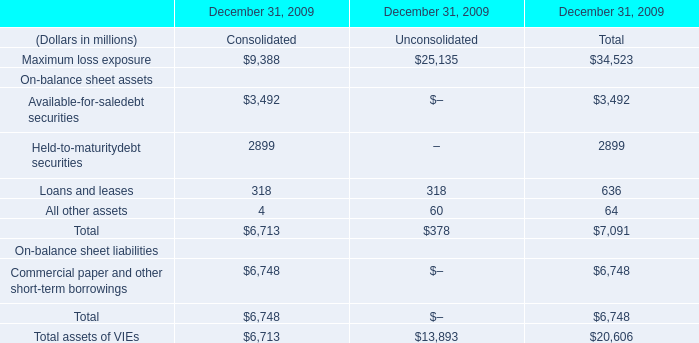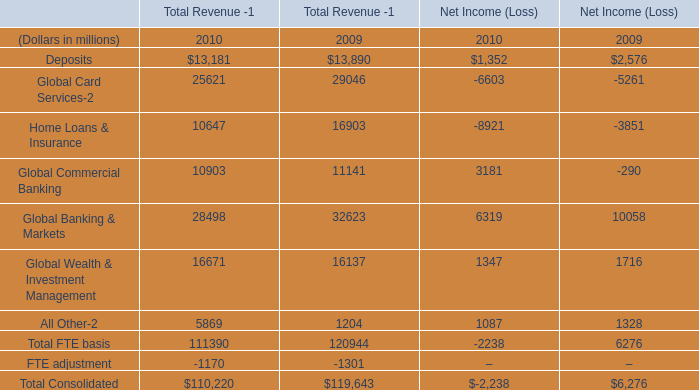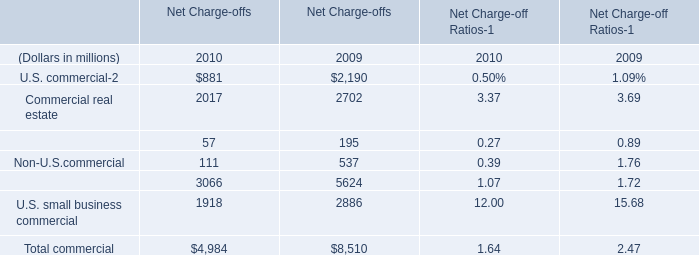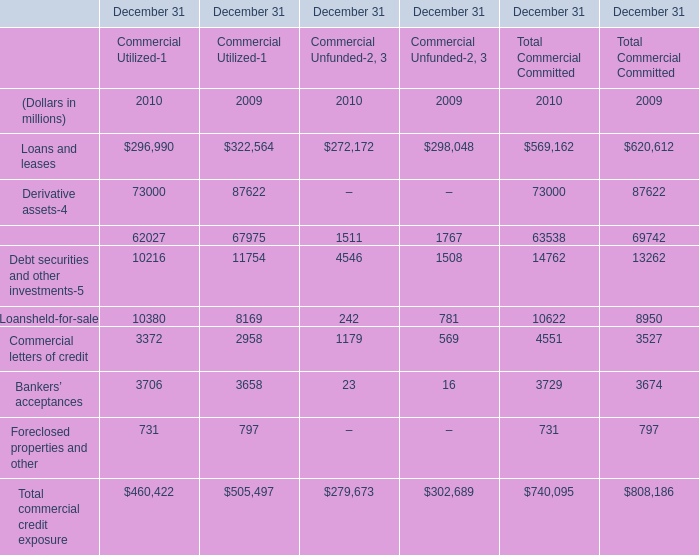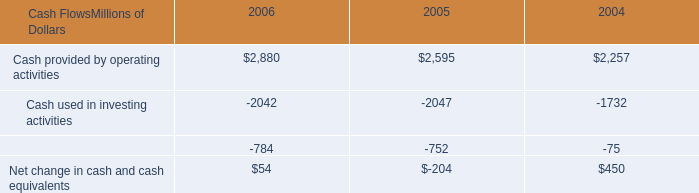If commercial letters of credit for Total Commercial Committed develops with the same growth rate in 2010, what will it reach in 2011?” (in million) 
Computations: ((((4551 - 3527) / 3527) + 1) * 4551)
Answer: 5872.29969. 